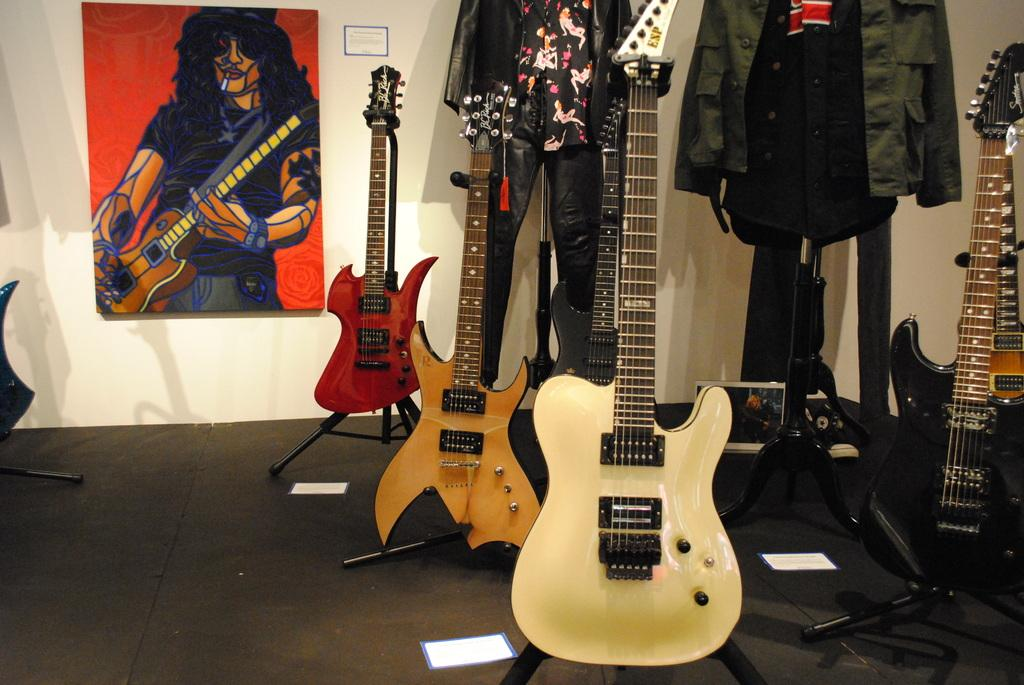How many guitars are visible in the image? There are four guitars in the image. What is the purpose of the stand in the image? The stand is used to hold a shirt in the image. Can you describe the shirt that is on the stand? The shirt is hanged on the stand. What else can be seen in the image related to guitars? There is a picture of a person holding a guitar in the image. What type of brass instrument is being played in the image? There is no brass instrument present in the image; it only features guitars. How does the harmony of the guitars contribute to the overall sound in the image? The image is a still photograph and does not have any sound, so it is not possible to determine the harmony of the guitars. 